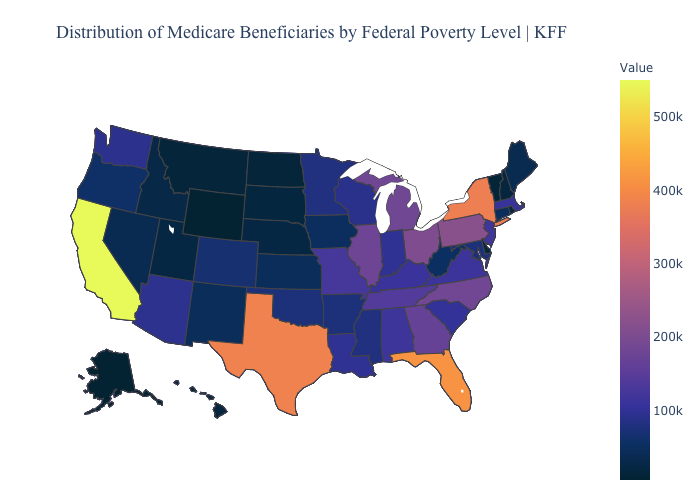Does Nebraska have the lowest value in the MidWest?
Answer briefly. No. Among the states that border Michigan , which have the highest value?
Keep it brief. Ohio. Which states have the highest value in the USA?
Concise answer only. California. Does Texas have a higher value than California?
Be succinct. No. Is the legend a continuous bar?
Answer briefly. Yes. Does Massachusetts have the lowest value in the USA?
Give a very brief answer. No. 